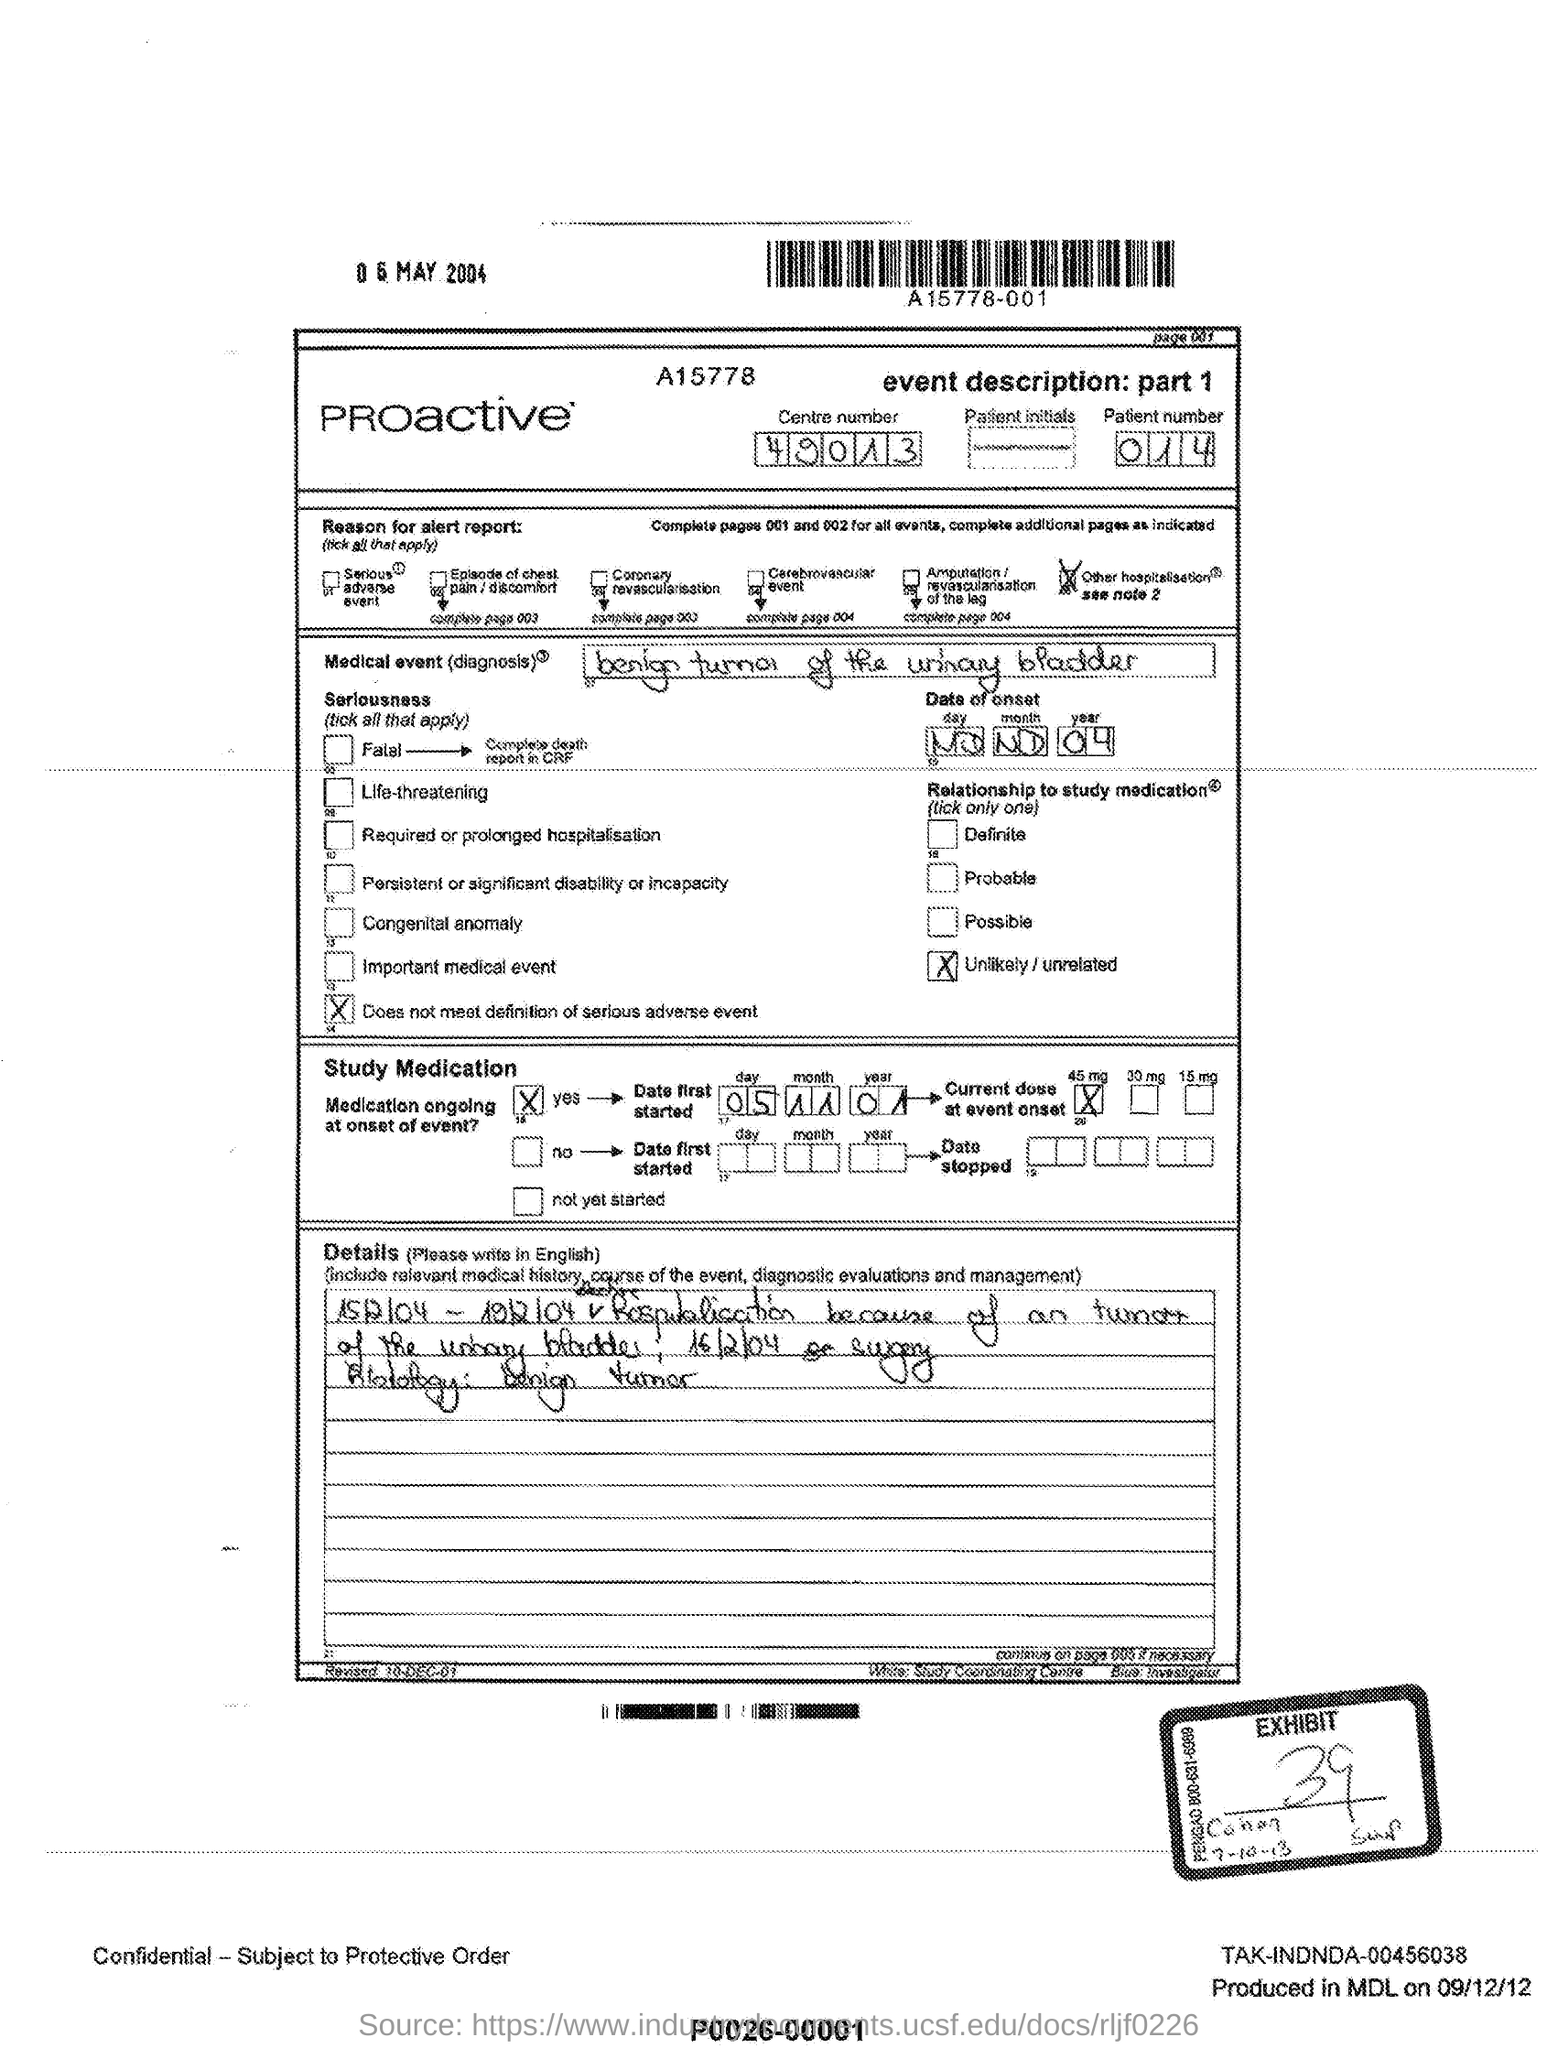Outline some significant characteristics in this image. What is the patient number? It is 014...  The exhibit number is 39. 